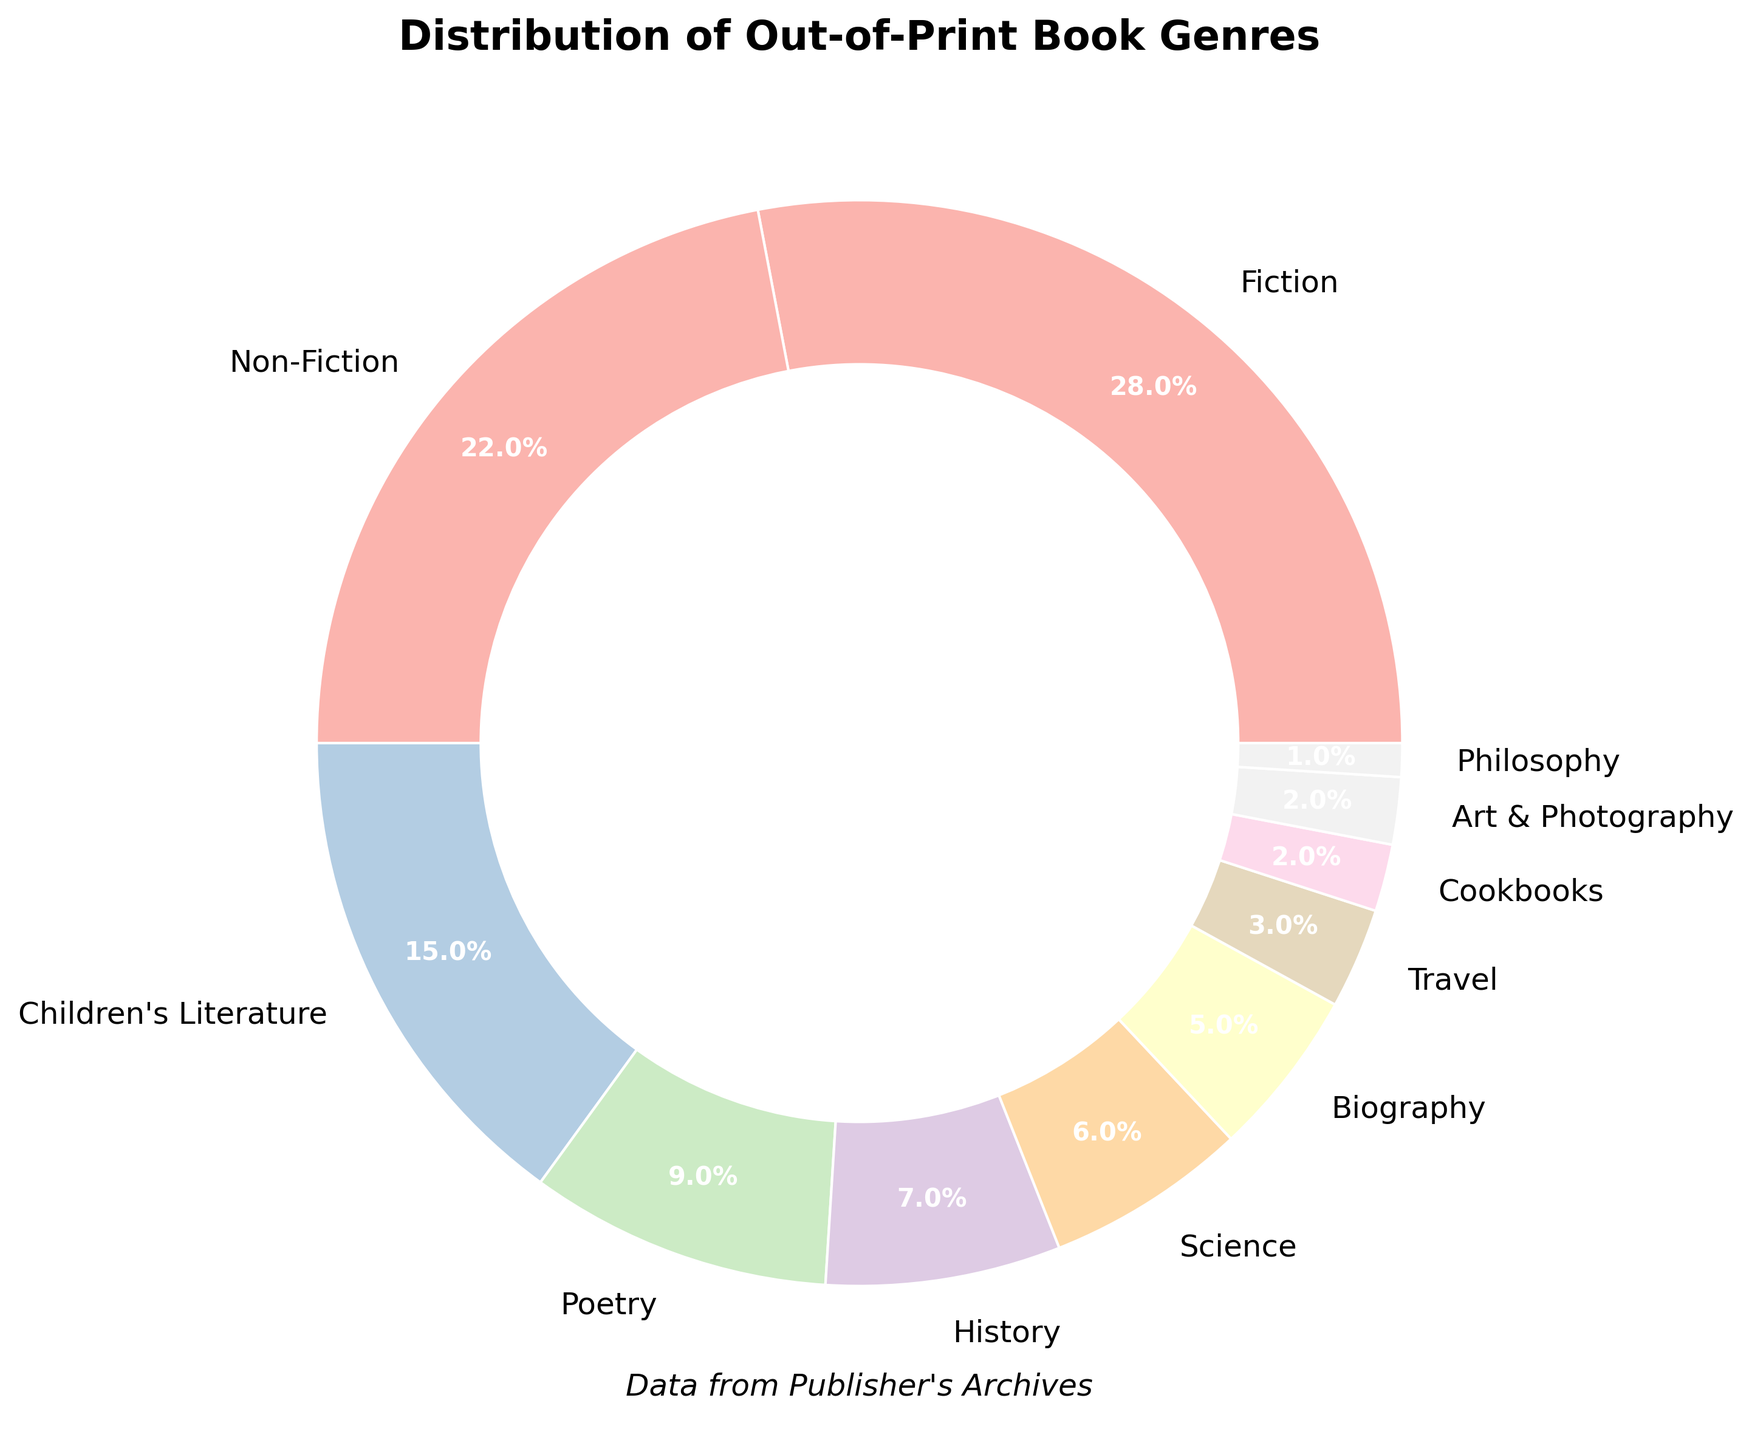What percentage of out-of-print books are Fiction or Non-Fiction combined? To find the combined percentage, sum the percentages of Fiction and Non-Fiction. Fiction is 28% and Non-Fiction is 22%, so 28% + 22% = 50%.
Answer: 50% Which genre has the smallest percentage of out-of-print books? By examining the pie chart, note that the smallest segment represents the genre with the smallest percentage. According to the data, Philosophy has the smallest share at 1%.
Answer: Philosophy Which genre has a larger share: Poetry or Biography? Refer to the pie chart and compare the wedges for Poetry and Biography. Poetry has 9% and Biography has 5%. Since 9% is greater than 5%, Poetry has a larger share.
Answer: Poetry Is the share of Cookbooks greater than or less than the share of Art & Photography? Check the respective segments in the pie chart: Cookbooks have 2% and Art & Photography also have 2%. Since both share the same percentage, they are equal.
Answer: Equal What's the difference in percentage between Fiction and Science genres? Calculate the difference by subtracting the percentage of Science from the percentage of Fiction. Fiction is at 28% and Science at 6%, so 28% - 6% = 22%.
Answer: 22% What percentage of the out-of-print books are either Travel or Cookbooks combined? To find the combined percentage, add the percentages of Travel and Cookbooks. Travel is at 3% and Cookbooks at 2%, resulting in 3% + 2% = 5%.
Answer: 5% How many genres have a percentage higher than 10%? Examine the pie chart and count the genres with percentages greater than 10%. The genres above this threshold are Fiction (28%), Non-Fiction (22%), and Children's Literature (15%), totaling 3 genres.
Answer: 3 Which genre forms the largest segment of the pie chart? By observing the pie chart, the largest segment belongs to the genre with the highest percentage. According to the data, this genre is Fiction at 28%.
Answer: Fiction If you were to equally distribute the percentage of Fiction into two different genres, what would be the new percentage for each? Divide the Fiction percentage (28%) by 2 to distribute it equally. 28% / 2 = 14%. Each new genre would have 14%.
Answer: 14% Comparing Science and History, which genre has a larger percentage and by how much? Science has 6% and History has 7%. History is larger by 1% (7% - 6% = 1%).
Answer: History by 1% 